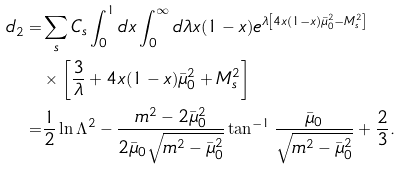Convert formula to latex. <formula><loc_0><loc_0><loc_500><loc_500>d _ { 2 } = & \sum _ { s } C _ { s } \int _ { 0 } ^ { 1 } d x \int _ { 0 } ^ { \infty } d \lambda x ( 1 - x ) e ^ { \lambda \left [ 4 x ( 1 - x ) \bar { \mu } _ { 0 } ^ { 2 } - M _ { s } ^ { 2 } \right ] } \\ & \times \left [ \frac { 3 } { \lambda } + 4 x ( 1 - x ) \bar { \mu } _ { 0 } ^ { 2 } + M _ { s } ^ { 2 } \right ] \\ = & \frac { 1 } { 2 } \ln \Lambda ^ { 2 } - \frac { m ^ { 2 } - 2 \bar { \mu } _ { 0 } ^ { 2 } } { 2 \bar { \mu } _ { 0 } \sqrt { m ^ { 2 } - \bar { \mu } _ { 0 } ^ { 2 } } } \tan ^ { - 1 } \frac { \bar { \mu } _ { 0 } } { \sqrt { m ^ { 2 } - \bar { \mu } _ { 0 } ^ { 2 } } } + \frac { 2 } { 3 } .</formula> 